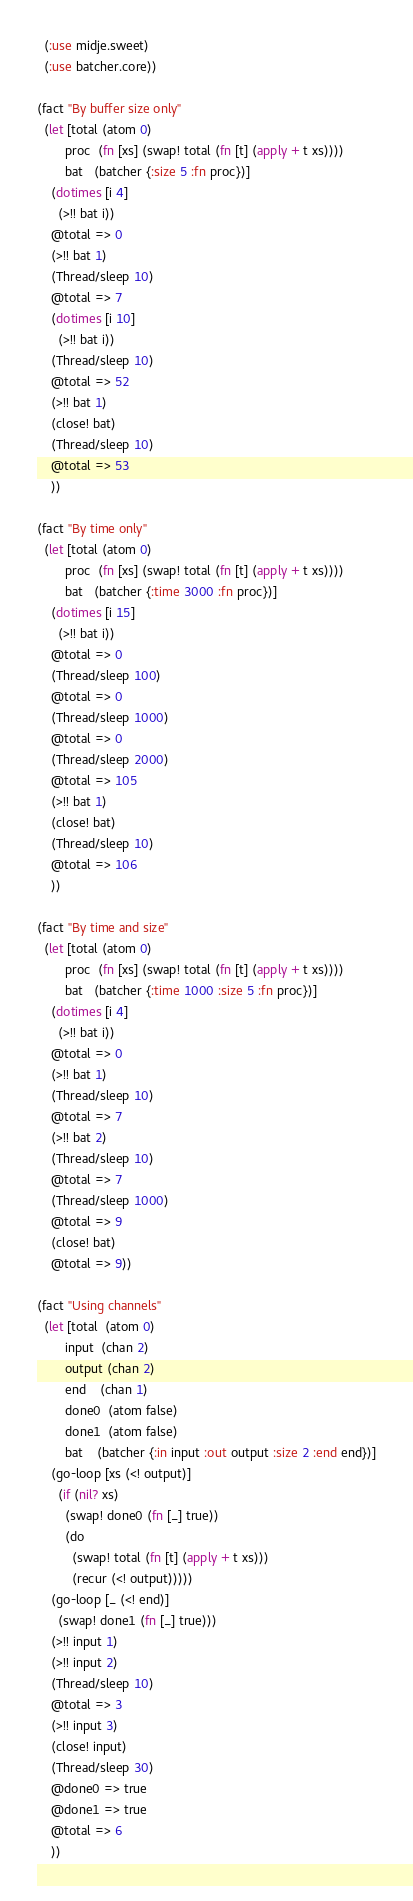Convert code to text. <code><loc_0><loc_0><loc_500><loc_500><_Clojure_>  (:use midje.sweet)
  (:use batcher.core))

(fact "By buffer size only"
  (let [total (atom 0)
        proc  (fn [xs] (swap! total (fn [t] (apply + t xs))))
        bat   (batcher {:size 5 :fn proc})]
    (dotimes [i 4]
      (>!! bat i))
    @total => 0
    (>!! bat 1)
    (Thread/sleep 10)
    @total => 7
    (dotimes [i 10]
      (>!! bat i))
    (Thread/sleep 10)
    @total => 52
    (>!! bat 1)
    (close! bat)
    (Thread/sleep 10)
    @total => 53
    ))

(fact "By time only"
  (let [total (atom 0)
        proc  (fn [xs] (swap! total (fn [t] (apply + t xs))))
        bat   (batcher {:time 3000 :fn proc})]
    (dotimes [i 15]
      (>!! bat i))
    @total => 0
    (Thread/sleep 100)
    @total => 0
    (Thread/sleep 1000)
    @total => 0
    (Thread/sleep 2000)
    @total => 105
    (>!! bat 1)
    (close! bat)
    (Thread/sleep 10)
    @total => 106
    ))

(fact "By time and size"
  (let [total (atom 0)
        proc  (fn [xs] (swap! total (fn [t] (apply + t xs))))
        bat   (batcher {:time 1000 :size 5 :fn proc})]
    (dotimes [i 4]
      (>!! bat i))
    @total => 0
    (>!! bat 1)
    (Thread/sleep 10)
    @total => 7
    (>!! bat 2)
    (Thread/sleep 10)
    @total => 7
    (Thread/sleep 1000)
    @total => 9
    (close! bat)
    @total => 9))

(fact "Using channels"
  (let [total  (atom 0)
        input  (chan 2)
        output (chan 2)
        end    (chan 1)
        done0  (atom false)
        done1  (atom false)
        bat    (batcher {:in input :out output :size 2 :end end})]
    (go-loop [xs (<! output)]
      (if (nil? xs)
        (swap! done0 (fn [_] true))
        (do
          (swap! total (fn [t] (apply + t xs)))
          (recur (<! output)))))
    (go-loop [_ (<! end)]
      (swap! done1 (fn [_] true)))
    (>!! input 1)
    (>!! input 2)
    (Thread/sleep 10)
    @total => 3
    (>!! input 3)
    (close! input)
    (Thread/sleep 30)
    @done0 => true
    @done1 => true
    @total => 6
    ))

</code> 